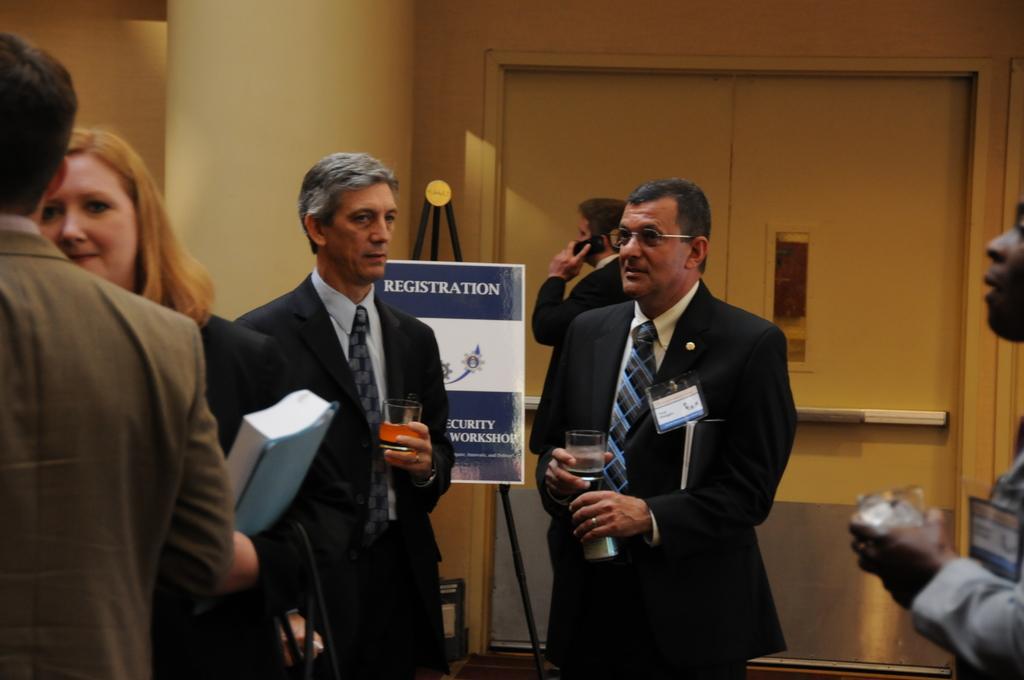Describe this image in one or two sentences. In the image we can see there are people wearing clothes and they are holding different objects in their hands. Here we can see the poster and text on it. Here we can see the door and the wall. 